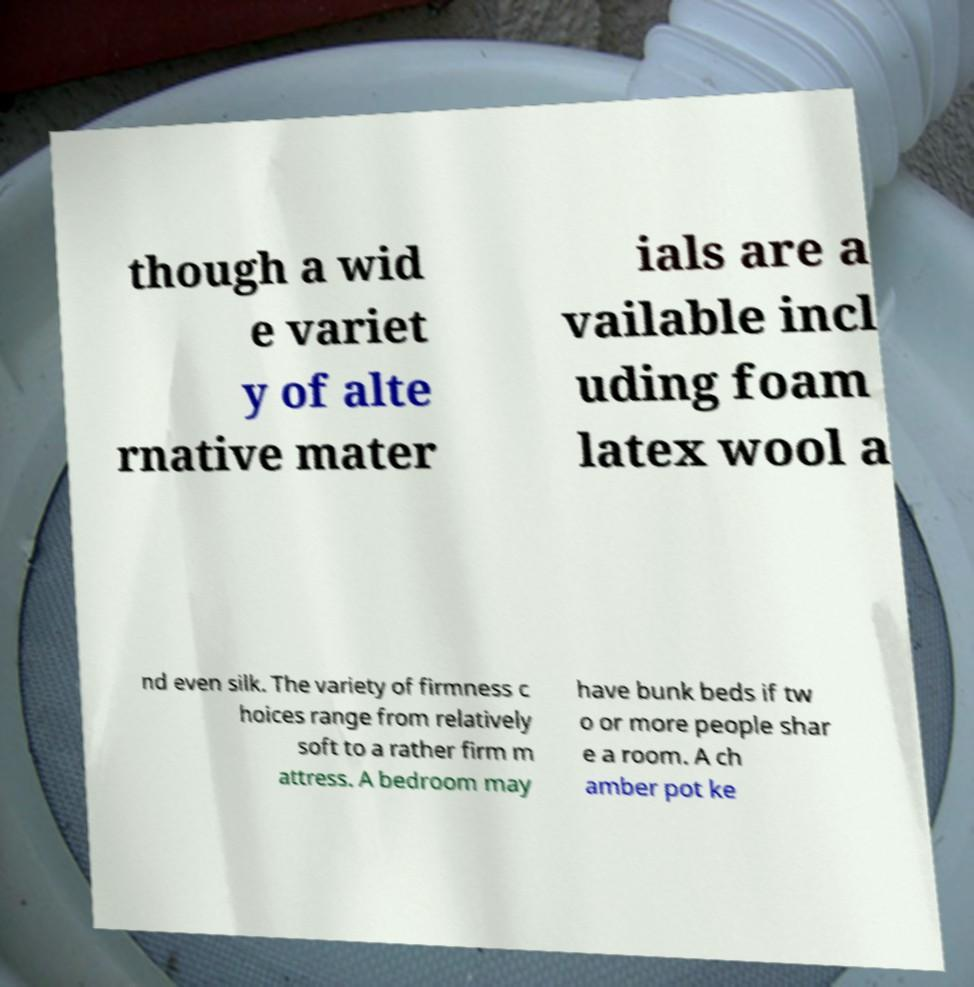Please identify and transcribe the text found in this image. though a wid e variet y of alte rnative mater ials are a vailable incl uding foam latex wool a nd even silk. The variety of firmness c hoices range from relatively soft to a rather firm m attress. A bedroom may have bunk beds if tw o or more people shar e a room. A ch amber pot ke 